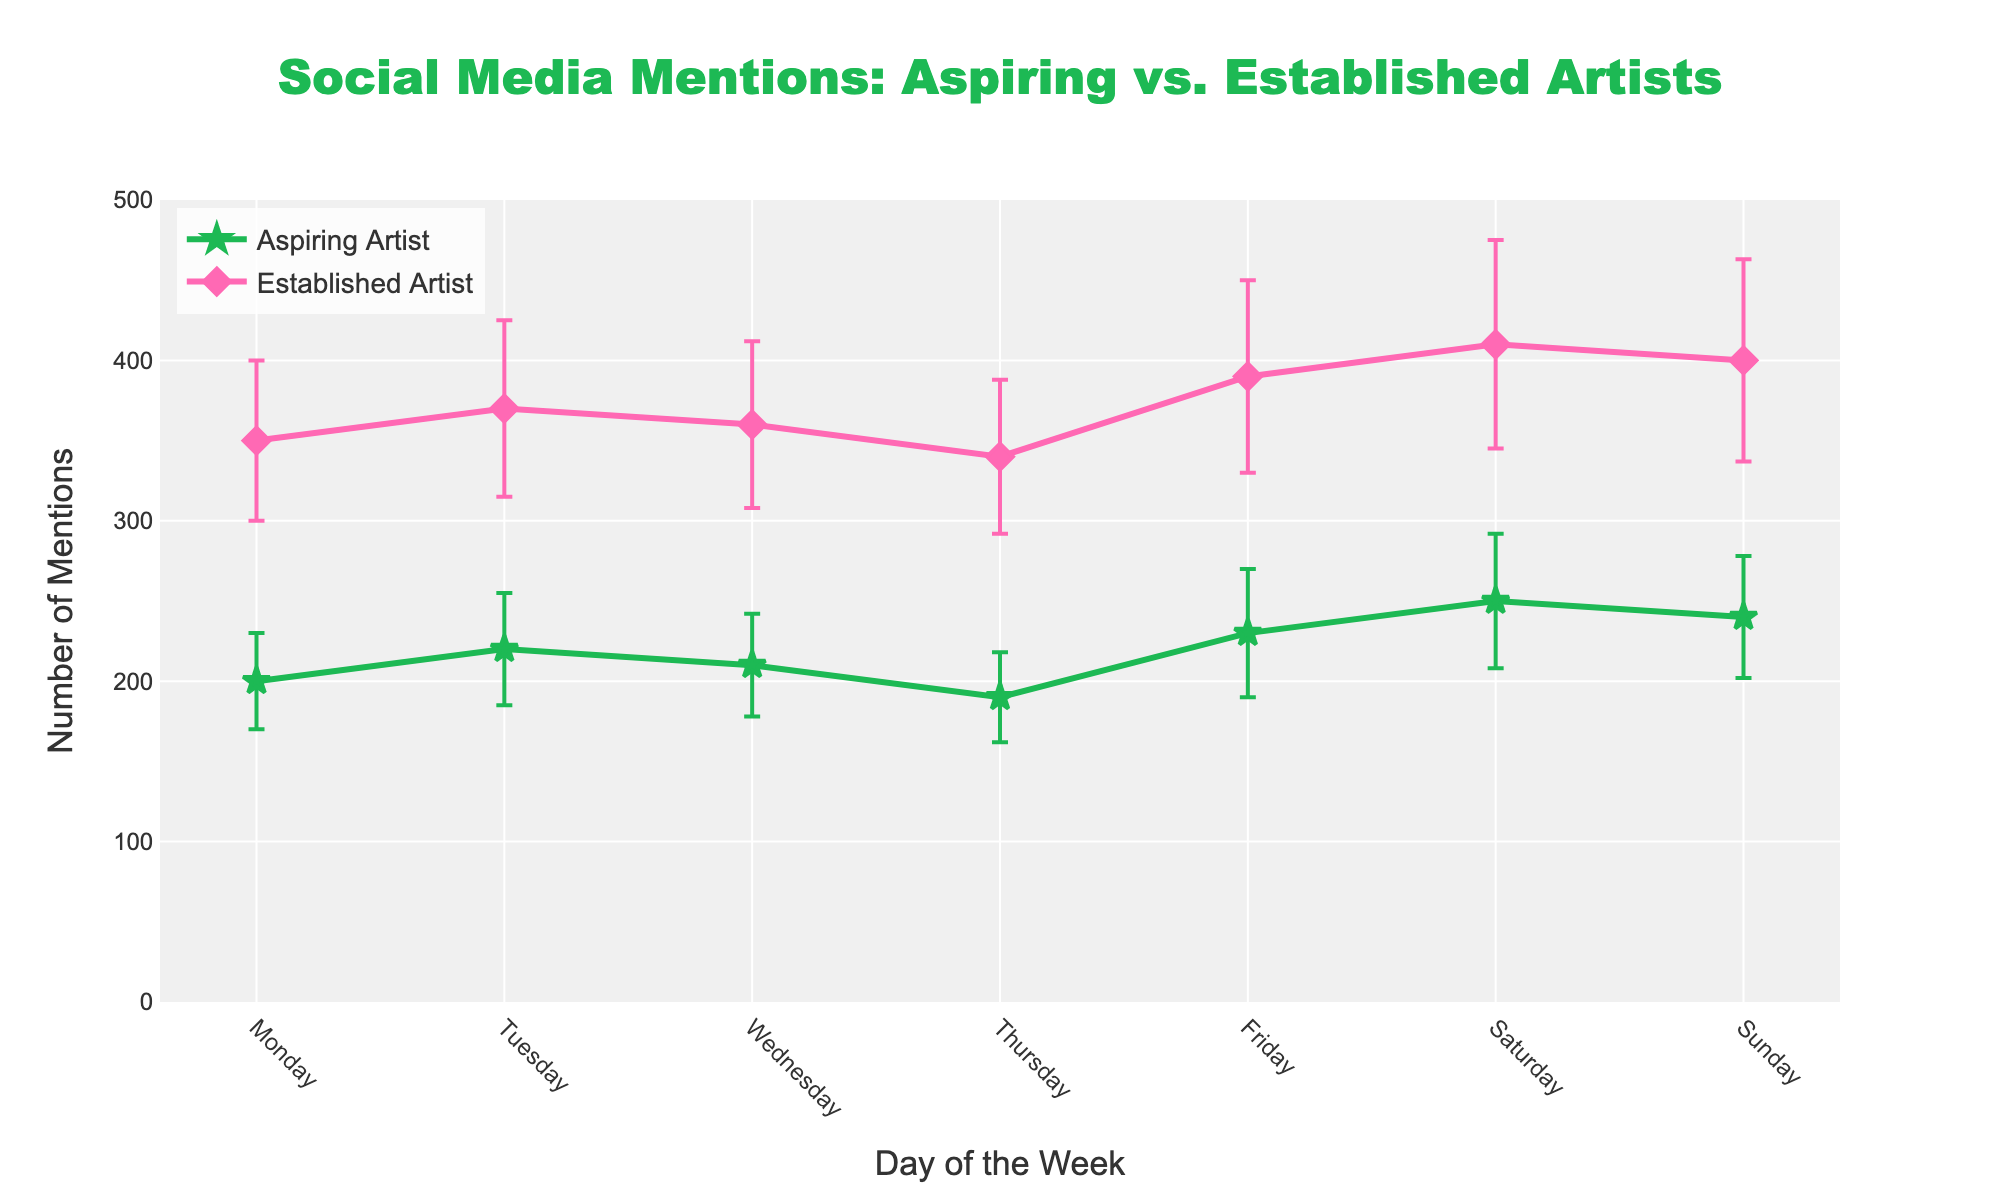Which day has the highest average mentions for aspiring artists? Observing the 'Aspiring Artist' series, Saturday has the highest average mention at 250.
Answer: Saturday How many days does the average mention for established artists exceed 350? By examining the 'Established Artist' series, mentions exceed 350 on Tuesday (370), Wednesday (360), Friday (390), Saturday (410), and Sunday (400), totaling up to 5 days.
Answer: 5 Which artist type shows greater variability in social media mentions throughout the week? Comparing the error bars, 'Established Artist' error bars are generally larger, indicating greater variability throughout the week.
Answer: Established Artist What is the difference in the average number of mentions between aspiring and established artists on Monday? The average mentions for aspiring artists on Monday is 200 and for established artists is 350. The difference is 350 - 200 = 150.
Answer: 150 On which day are the standard deviations for mentions equal for both aspiring and established artists? By inspecting the error bars, none of the days show equal standard deviations; each day has different variability.
Answer: None How many days do aspiring artists have an average mention count greater than their mean on Wednesday? Mean for aspiring artists on Wednesday is 210. Comparing to other days: Monday (200 < 210), Tuesday (220 > 210), Thursday (190 < 210), Friday (230 > 210), Saturday (250 > 210), Sunday (240 > 210). This occurs on Tuesday, Friday, Saturday, and Sunday, totaling 4 days.
Answer: 4 What is the average number of mentions for established artists over the weekend (Saturday and Sunday)? Average mentions for established artists are 410 (Saturday) and 400 (Sunday). The average over the weekend is (410 + 400) / 2 = 405.
Answer: 405 Which day shows the lowest average mentions for aspiring artists, and what is the value? By reviewing the daily mentions for aspiring artists, Thursday shows the lowest average at 190.
Answer: Thursday, 190 Compare the average number of mentions on Friday for both types of artists. Which has more, and by how much? Aspiring artists have 230 mentions, and established artists have 390 mentions on Friday. Established artists have more by 390 - 230 = 160.
Answer: Established Artists by 160 What are the average mentions for established artists on the days with peak and trough mentions? Peak mentions for established artists: Saturday (410). Trough mentions: Thursday (340).
Answer: Peak 410, Trough 340 